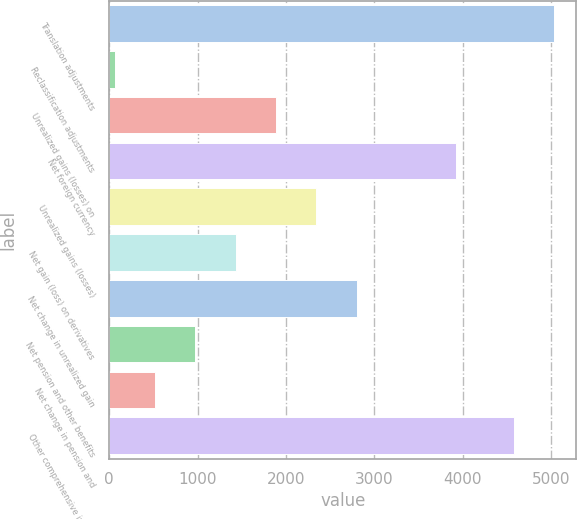Convert chart. <chart><loc_0><loc_0><loc_500><loc_500><bar_chart><fcel>Translation adjustments<fcel>Reclassification adjustments<fcel>Unrealized gains (losses) on<fcel>Net foreign currency<fcel>Unrealized gains (losses)<fcel>Net gain (loss) on derivatives<fcel>Net change in unrealized gain<fcel>Net pension and other benefits<fcel>Net change in pension and<fcel>Other comprehensive income<nl><fcel>5033.3<fcel>63<fcel>1888.2<fcel>3926<fcel>2344.5<fcel>1431.9<fcel>2800.8<fcel>975.6<fcel>519.3<fcel>4577<nl></chart> 